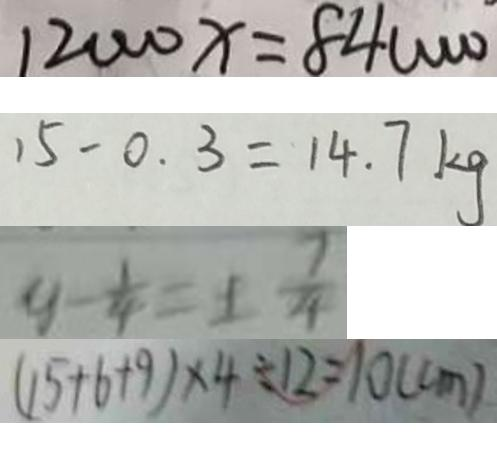Convert formula to latex. <formula><loc_0><loc_0><loc_500><loc_500>1 2 0 0 0 x = 8 4 0 0 0 0 ^ { \cdot } 
 1 5 - 0 . 3 = 1 4 . 7 k g 
 y - \frac { 1 } { 4 } = \pm \frac { 7 } { 4 } 
 ( 1 5 + 6 + 9 ) \times 4 \div 1 2 = 1 0 ( c m )</formula> 